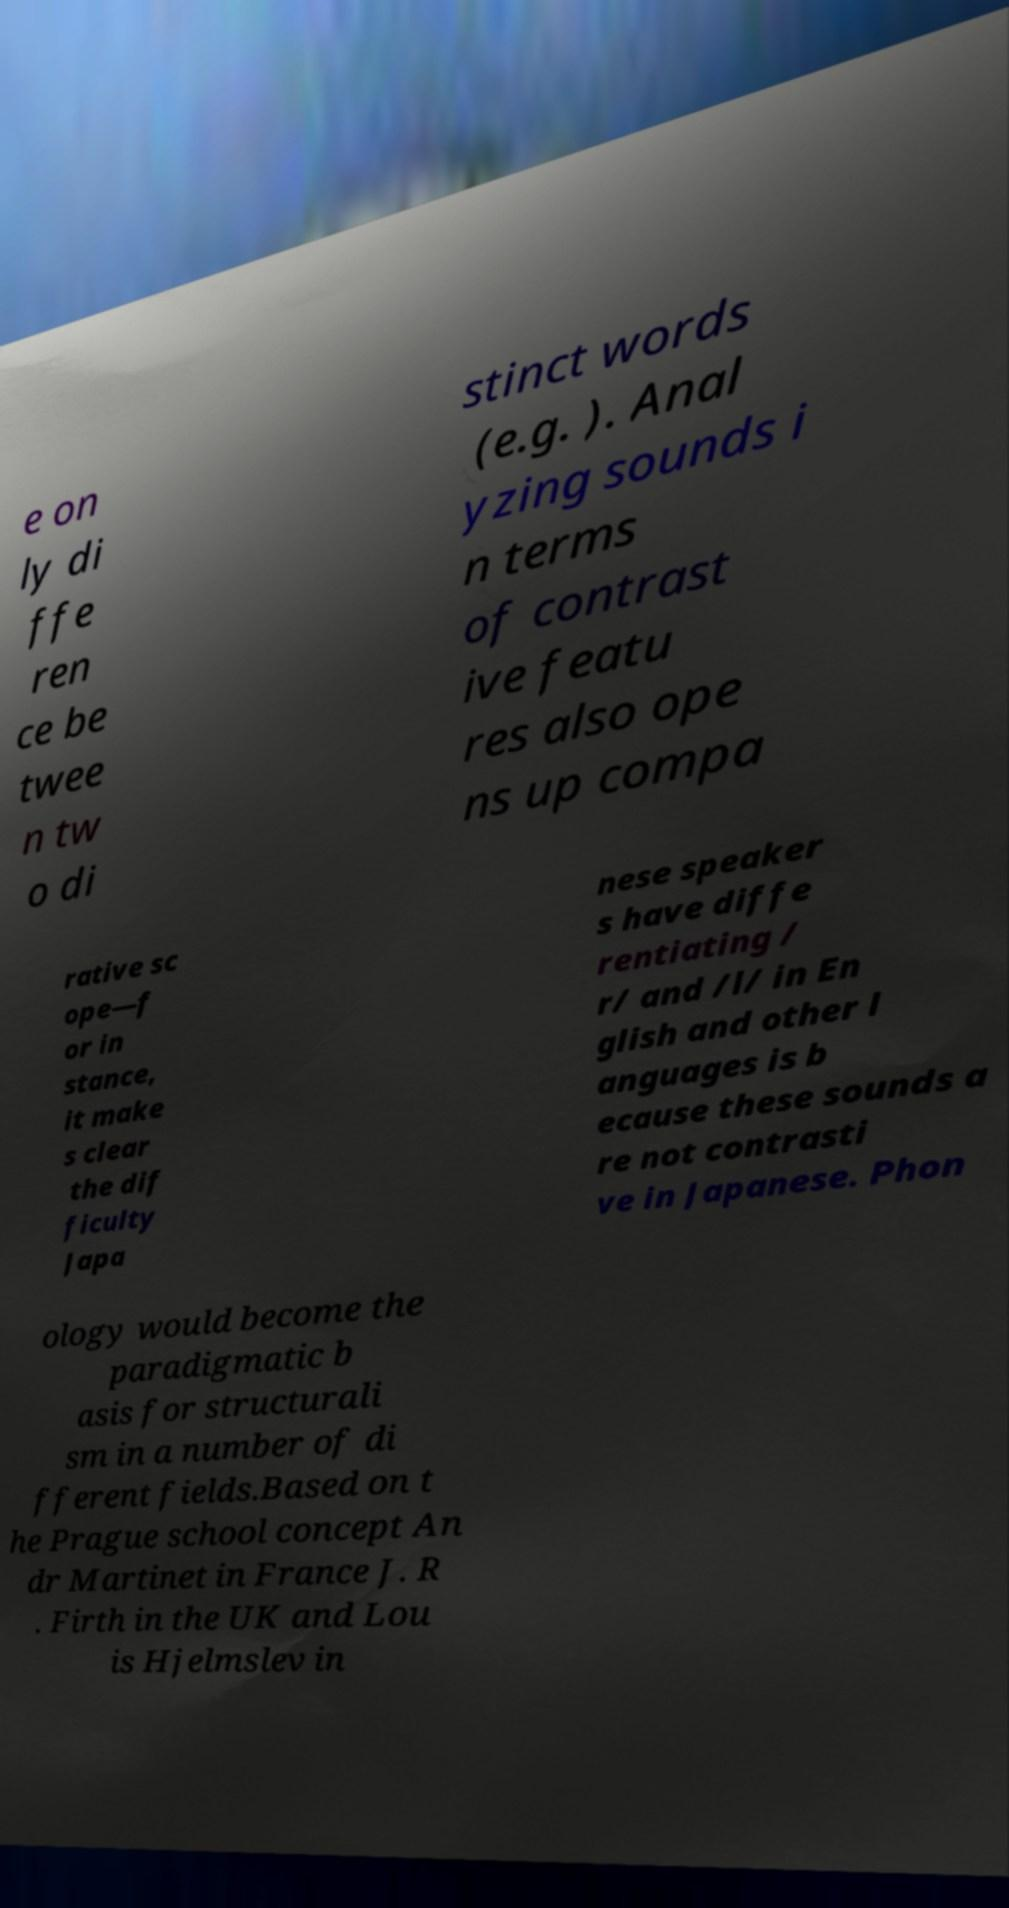Please read and relay the text visible in this image. What does it say? e on ly di ffe ren ce be twee n tw o di stinct words (e.g. ). Anal yzing sounds i n terms of contrast ive featu res also ope ns up compa rative sc ope—f or in stance, it make s clear the dif ficulty Japa nese speaker s have diffe rentiating / r/ and /l/ in En glish and other l anguages is b ecause these sounds a re not contrasti ve in Japanese. Phon ology would become the paradigmatic b asis for structurali sm in a number of di fferent fields.Based on t he Prague school concept An dr Martinet in France J. R . Firth in the UK and Lou is Hjelmslev in 